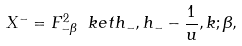<formula> <loc_0><loc_0><loc_500><loc_500>X ^ { - } = F ^ { 2 } _ { - \beta } \ k e t { h _ { - } , h _ { - } - \frac { 1 } { u } , k ; \beta } ,</formula> 